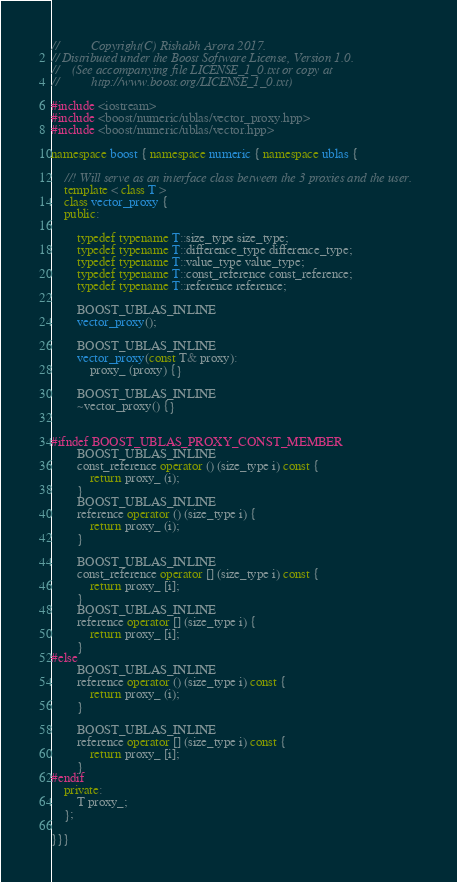<code> <loc_0><loc_0><loc_500><loc_500><_C++_>//          Copyright(C) Rishabh Arora 2017.
// Distributed under the Boost Software License, Version 1.0.
//    (See accompanying file LICENSE_1_0.txt or copy at
//          http://www.boost.org/LICENSE_1_0.txt)

#include <iostream>
#include <boost/numeric/ublas/vector_proxy.hpp>
#include <boost/numeric/ublas/vector.hpp>

namespace boost { namespace numeric { namespace ublas {

	//! Will serve as an interface class between the 3 proxies and the user.
	template < class T >
	class vector_proxy {
	public:

		typedef typename T::size_type size_type;
        typedef typename T::difference_type difference_type;
        typedef typename T::value_type value_type;
        typedef typename T::const_reference const_reference;
        typedef typename T::reference reference;

		BOOST_UBLAS_INLINE
		vector_proxy();

		BOOST_UBLAS_INLINE
		vector_proxy(const T& proxy): 
			proxy_ (proxy) {}
           
 		BOOST_UBLAS_INLINE
		~vector_proxy() {}

		
#ifndef BOOST_UBLAS_PROXY_CONST_MEMBER
        BOOST_UBLAS_INLINE
        const_reference operator () (size_type i) const {
            return proxy_ (i);
        }
        BOOST_UBLAS_INLINE
        reference operator () (size_type i) {
         	return proxy_ (i);
        }

        BOOST_UBLAS_INLINE
        const_reference operator [] (size_type i) const {
         	return proxy_ [i];
        }
        BOOST_UBLAS_INLINE
        reference operator [] (size_type i) {
        	return proxy_ [i];
        }
#else
        BOOST_UBLAS_INLINE
        reference operator () (size_type i) const {
            return proxy_ (i);
        }

        BOOST_UBLAS_INLINE
        reference operator [] (size_type i) const {
            return proxy_ [i];
        }
#endif
	private:	
		T proxy_;
	};

}}}
</code> 